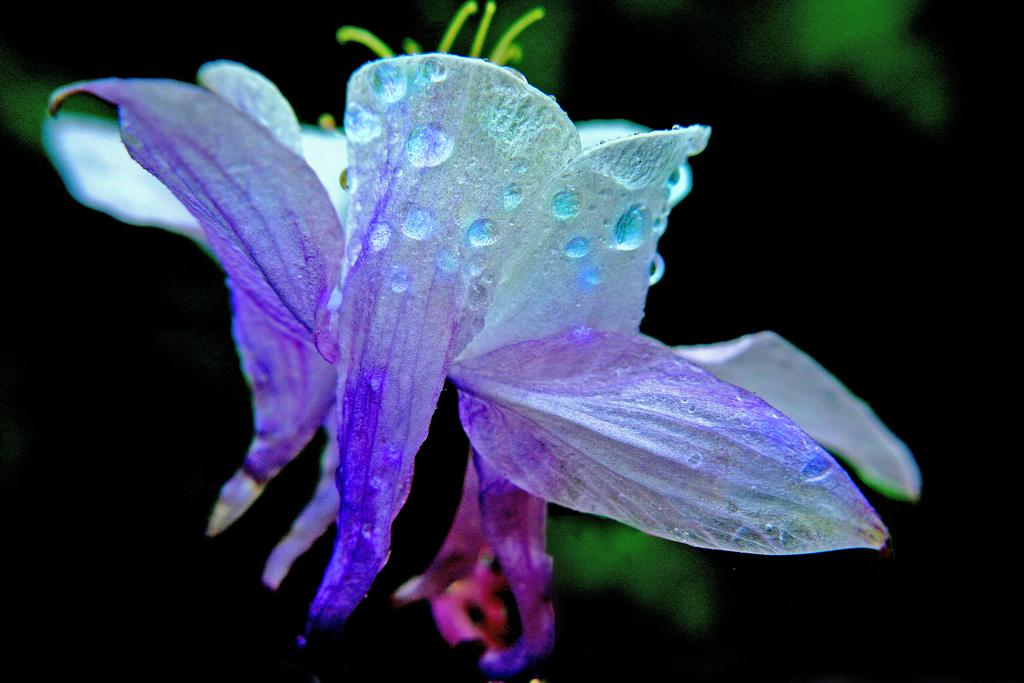What is located in the center of the image? There are flowers in the center of the image. Can you describe the flowers in the image? The flowers have water drops on them. What type of gold material is used to make the flowers in the image? There is no gold material present in the image; the flowers are made of natural plant material. 